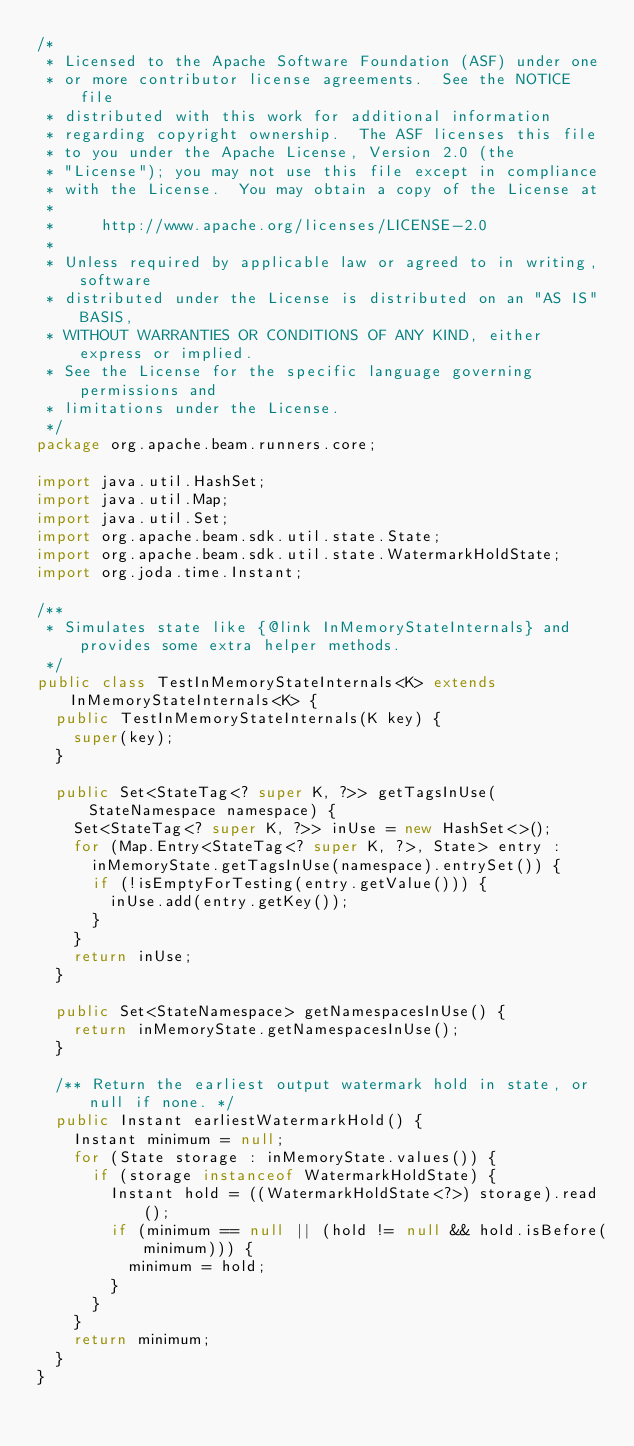Convert code to text. <code><loc_0><loc_0><loc_500><loc_500><_Java_>/*
 * Licensed to the Apache Software Foundation (ASF) under one
 * or more contributor license agreements.  See the NOTICE file
 * distributed with this work for additional information
 * regarding copyright ownership.  The ASF licenses this file
 * to you under the Apache License, Version 2.0 (the
 * "License"); you may not use this file except in compliance
 * with the License.  You may obtain a copy of the License at
 *
 *     http://www.apache.org/licenses/LICENSE-2.0
 *
 * Unless required by applicable law or agreed to in writing, software
 * distributed under the License is distributed on an "AS IS" BASIS,
 * WITHOUT WARRANTIES OR CONDITIONS OF ANY KIND, either express or implied.
 * See the License for the specific language governing permissions and
 * limitations under the License.
 */
package org.apache.beam.runners.core;

import java.util.HashSet;
import java.util.Map;
import java.util.Set;
import org.apache.beam.sdk.util.state.State;
import org.apache.beam.sdk.util.state.WatermarkHoldState;
import org.joda.time.Instant;

/**
 * Simulates state like {@link InMemoryStateInternals} and provides some extra helper methods.
 */
public class TestInMemoryStateInternals<K> extends InMemoryStateInternals<K> {
  public TestInMemoryStateInternals(K key) {
    super(key);
  }

  public Set<StateTag<? super K, ?>> getTagsInUse(StateNamespace namespace) {
    Set<StateTag<? super K, ?>> inUse = new HashSet<>();
    for (Map.Entry<StateTag<? super K, ?>, State> entry :
      inMemoryState.getTagsInUse(namespace).entrySet()) {
      if (!isEmptyForTesting(entry.getValue())) {
        inUse.add(entry.getKey());
      }
    }
    return inUse;
  }

  public Set<StateNamespace> getNamespacesInUse() {
    return inMemoryState.getNamespacesInUse();
  }

  /** Return the earliest output watermark hold in state, or null if none. */
  public Instant earliestWatermarkHold() {
    Instant minimum = null;
    for (State storage : inMemoryState.values()) {
      if (storage instanceof WatermarkHoldState) {
        Instant hold = ((WatermarkHoldState<?>) storage).read();
        if (minimum == null || (hold != null && hold.isBefore(minimum))) {
          minimum = hold;
        }
      }
    }
    return minimum;
  }
}
</code> 